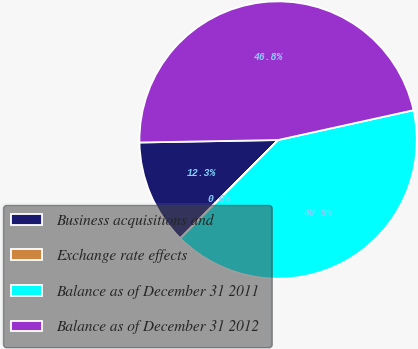<chart> <loc_0><loc_0><loc_500><loc_500><pie_chart><fcel>Business acquisitions and<fcel>Exchange rate effects<fcel>Balance as of December 31 2011<fcel>Balance as of December 31 2012<nl><fcel>12.25%<fcel>0.02%<fcel>40.89%<fcel>46.83%<nl></chart> 